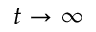Convert formula to latex. <formula><loc_0><loc_0><loc_500><loc_500>t \rightarrow \infty</formula> 